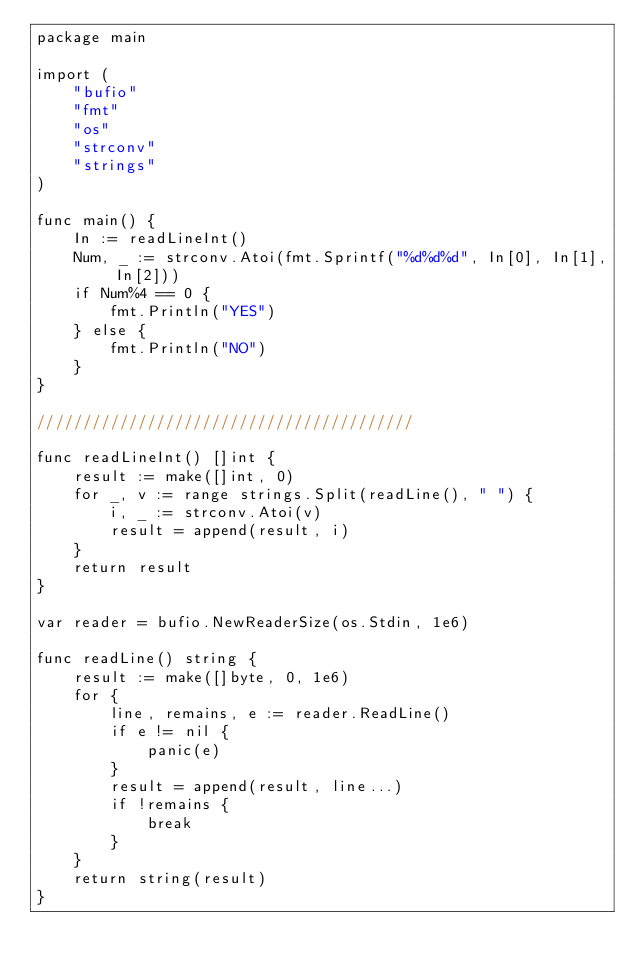<code> <loc_0><loc_0><loc_500><loc_500><_Go_>package main

import (
	"bufio"
	"fmt"
	"os"
	"strconv"
	"strings"
)

func main() {
	In := readLineInt()
	Num, _ := strconv.Atoi(fmt.Sprintf("%d%d%d", In[0], In[1], In[2]))
	if Num%4 == 0 {
		fmt.Println("YES")
	} else {
		fmt.Println("NO")
	}
}

/////////////////////////////////////////

func readLineInt() []int {
	result := make([]int, 0)
	for _, v := range strings.Split(readLine(), " ") {
		i, _ := strconv.Atoi(v)
		result = append(result, i)
	}
	return result
}

var reader = bufio.NewReaderSize(os.Stdin, 1e6)

func readLine() string {
	result := make([]byte, 0, 1e6)
	for {
		line, remains, e := reader.ReadLine()
		if e != nil {
			panic(e)
		}
		result = append(result, line...)
		if !remains {
			break
		}
	}
	return string(result)
}</code> 